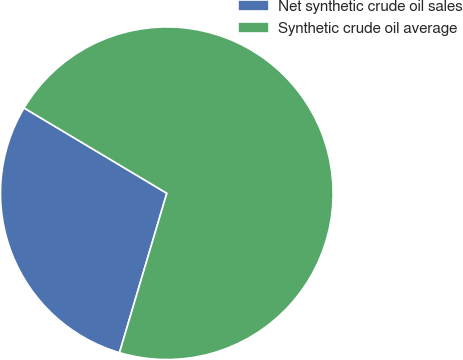Convert chart. <chart><loc_0><loc_0><loc_500><loc_500><pie_chart><fcel>Net synthetic crude oil sales<fcel>Synthetic crude oil average<nl><fcel>28.98%<fcel>71.02%<nl></chart> 